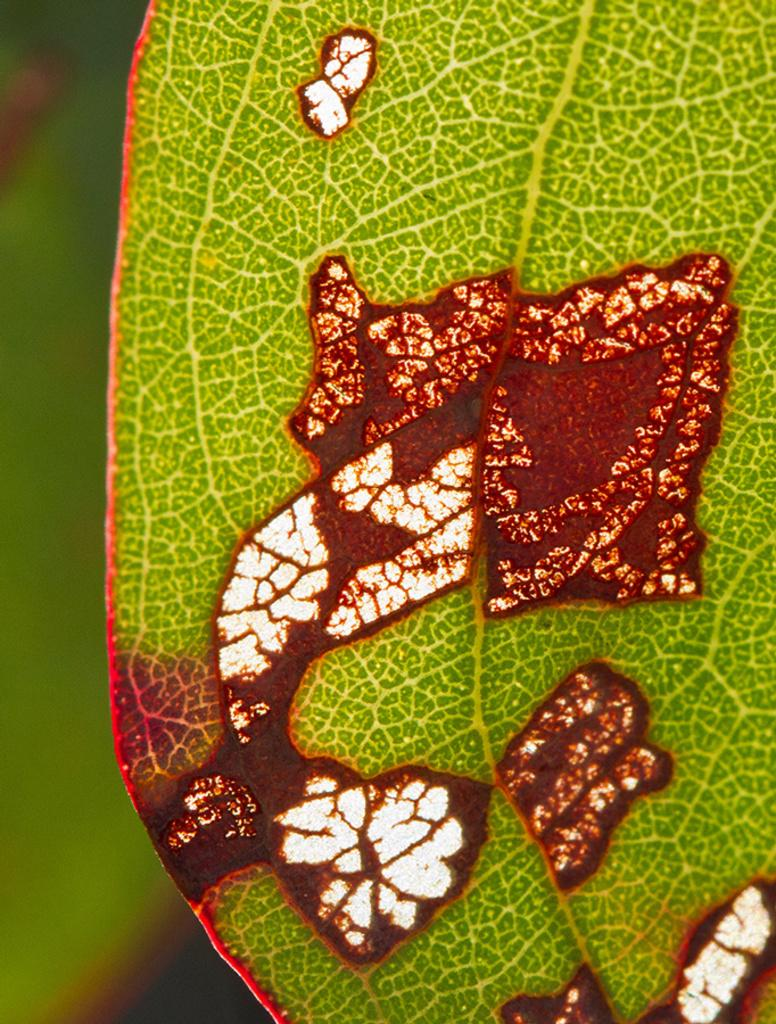What is the main subject of the image? The main subject of the image is a leaf. Can you describe the background of the image? The background of the image is blurred. What type of locket is hanging from the leaf in the image? There is no locket present in the image; it only features a leaf with a blurred background. What thrilling activity is taking place in the image? There is no thrilling activity depicted in the image; it simply shows a leaf with a blurred background. 